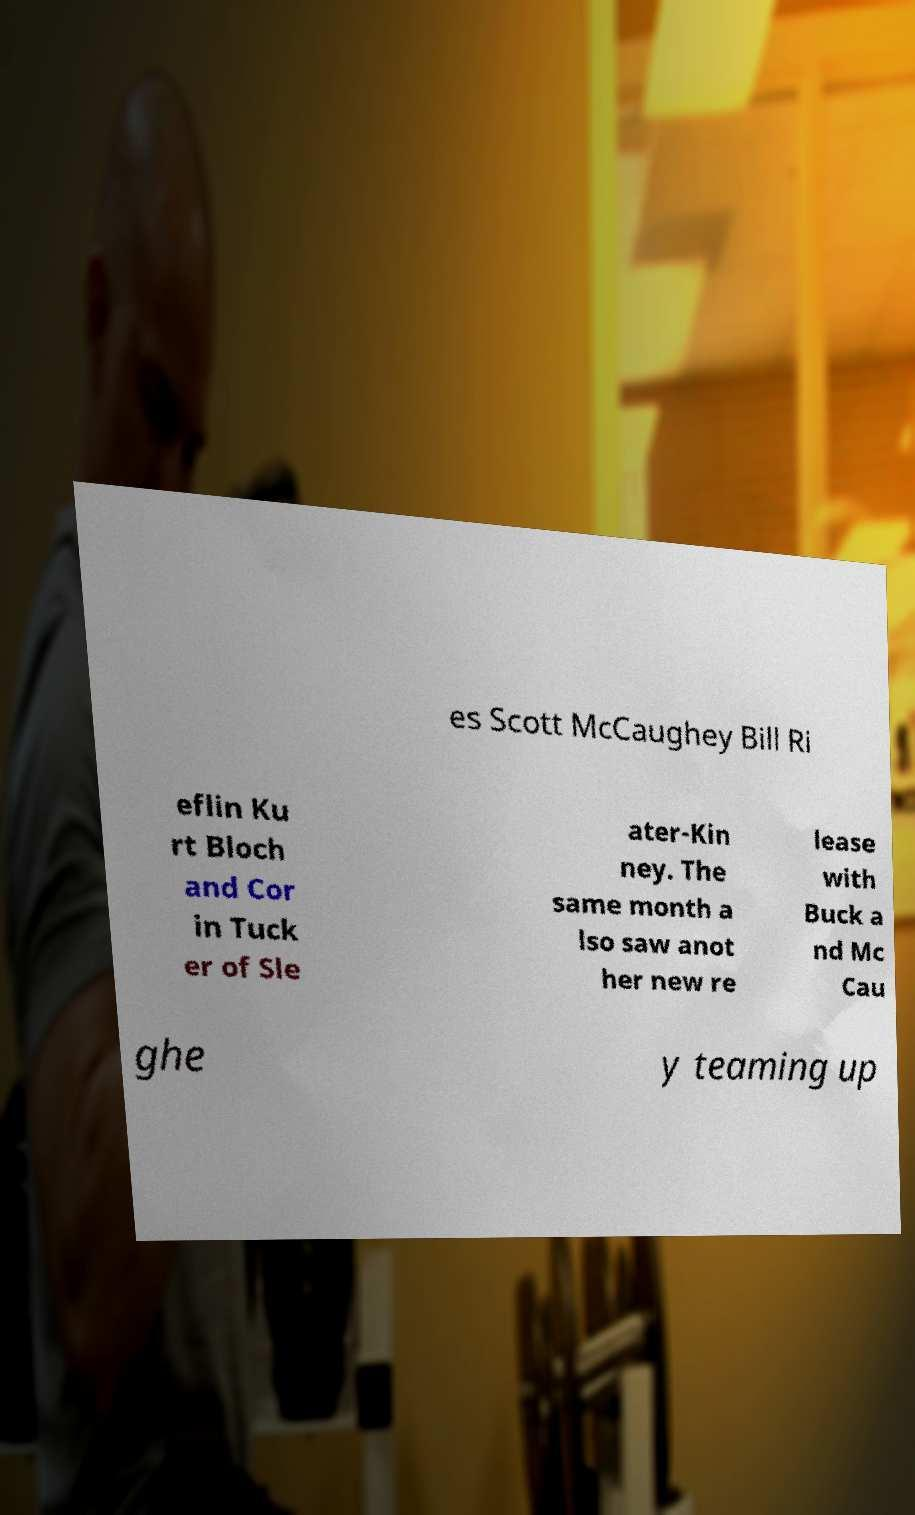There's text embedded in this image that I need extracted. Can you transcribe it verbatim? es Scott McCaughey Bill Ri eflin Ku rt Bloch and Cor in Tuck er of Sle ater-Kin ney. The same month a lso saw anot her new re lease with Buck a nd Mc Cau ghe y teaming up 